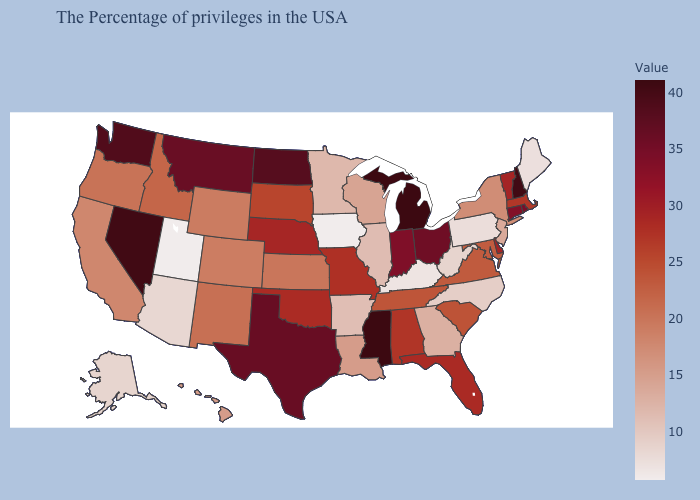Among the states that border Louisiana , does Arkansas have the lowest value?
Give a very brief answer. Yes. Which states have the highest value in the USA?
Answer briefly. Michigan, Mississippi. Which states have the lowest value in the USA?
Quick response, please. Iowa, Utah. Is the legend a continuous bar?
Concise answer only. Yes. Does Nevada have the lowest value in the USA?
Give a very brief answer. No. Does Iowa have the lowest value in the USA?
Quick response, please. Yes. Does Florida have a lower value than Louisiana?
Quick response, please. No. 